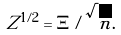Convert formula to latex. <formula><loc_0><loc_0><loc_500><loc_500>Z ^ { 1 / 2 } = \Xi / \sqrt { n } .</formula> 